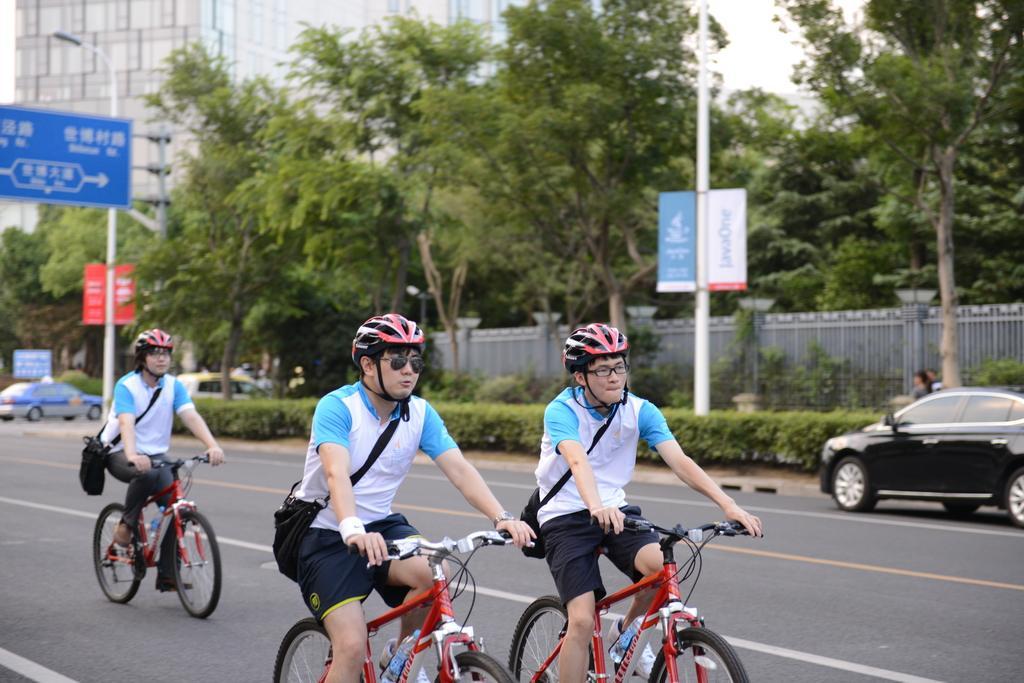Could you give a brief overview of what you see in this image? In this picture we can see three men wore helmet, goggles carrying bags and riding bicycles on road and beside to this road we have trees, fence, pole, banner, buildings, traffic light, cars, some persons. 